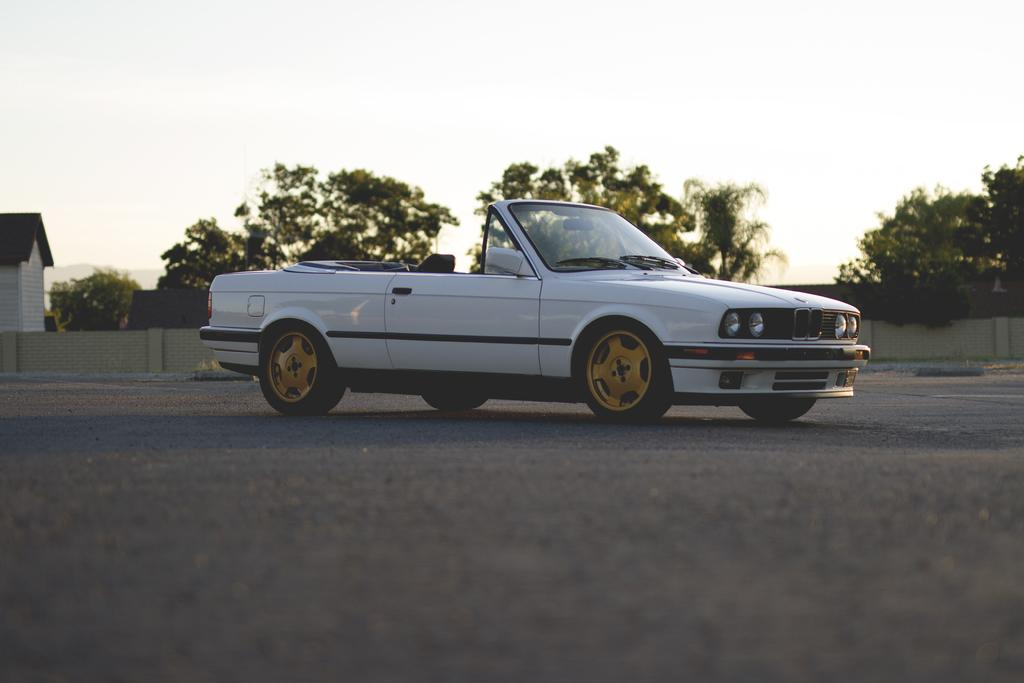What is the main subject of the image? The main subject of the image is a car on the road. What can be seen in the background of the image? Walls, trees, a house, and the sky are visible in the background of the image. Can you describe the setting of the image? The image shows a car on a road with a residential area in the background, including walls, trees, a house, and the sky. What type of oatmeal is being served in the image? There is no oatmeal present in the image; it features a car on a road with a residential area in the background. How many men are visible in the image? There are no men visible in the image; it shows a car on a road with a residential area in the background. 